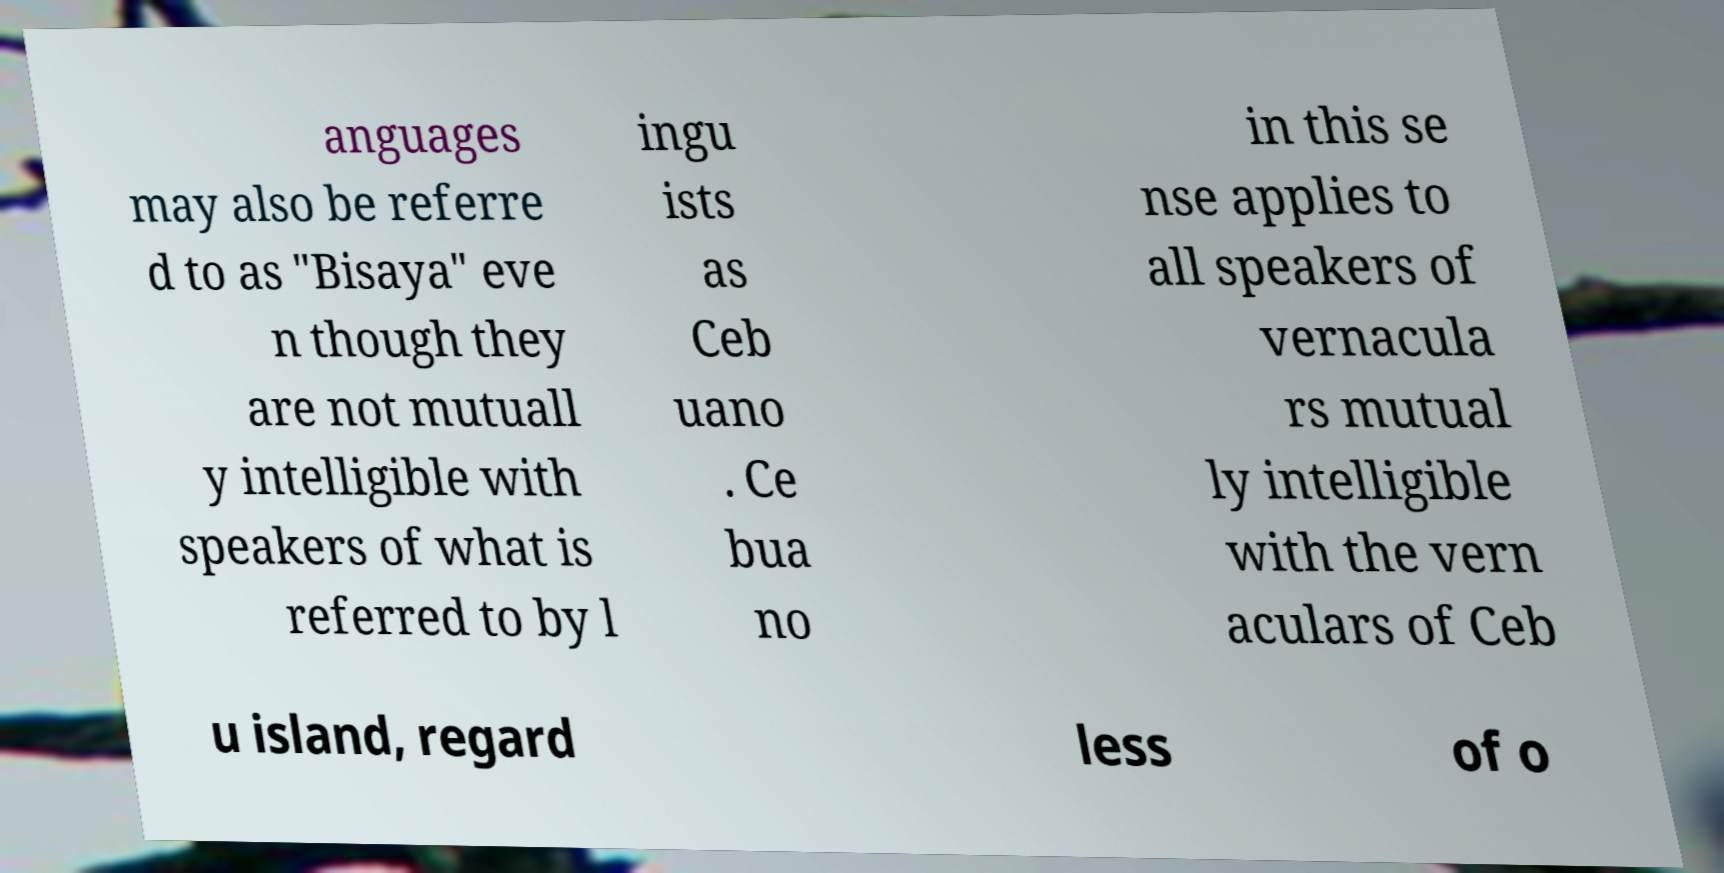For documentation purposes, I need the text within this image transcribed. Could you provide that? anguages may also be referre d to as "Bisaya" eve n though they are not mutuall y intelligible with speakers of what is referred to by l ingu ists as Ceb uano . Ce bua no in this se nse applies to all speakers of vernacula rs mutual ly intelligible with the vern aculars of Ceb u island, regard less of o 